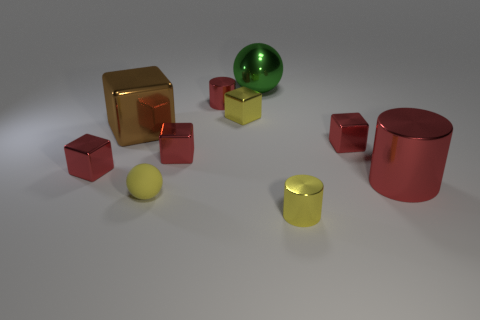Subtract all gray balls. How many red cubes are left? 3 Subtract all yellow blocks. How many blocks are left? 4 Subtract all small yellow metal blocks. How many blocks are left? 4 Subtract all gray blocks. Subtract all purple balls. How many blocks are left? 5 Subtract all cylinders. How many objects are left? 7 Subtract 0 green cylinders. How many objects are left? 10 Subtract all balls. Subtract all large green things. How many objects are left? 7 Add 6 rubber balls. How many rubber balls are left? 7 Add 2 matte things. How many matte things exist? 3 